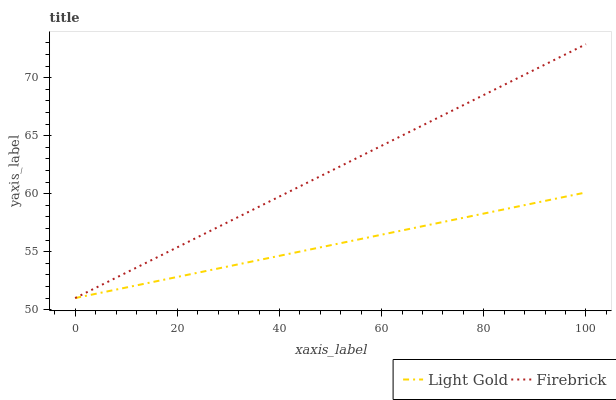Does Light Gold have the maximum area under the curve?
Answer yes or no. No. Is Light Gold the roughest?
Answer yes or no. No. Does Light Gold have the highest value?
Answer yes or no. No. 